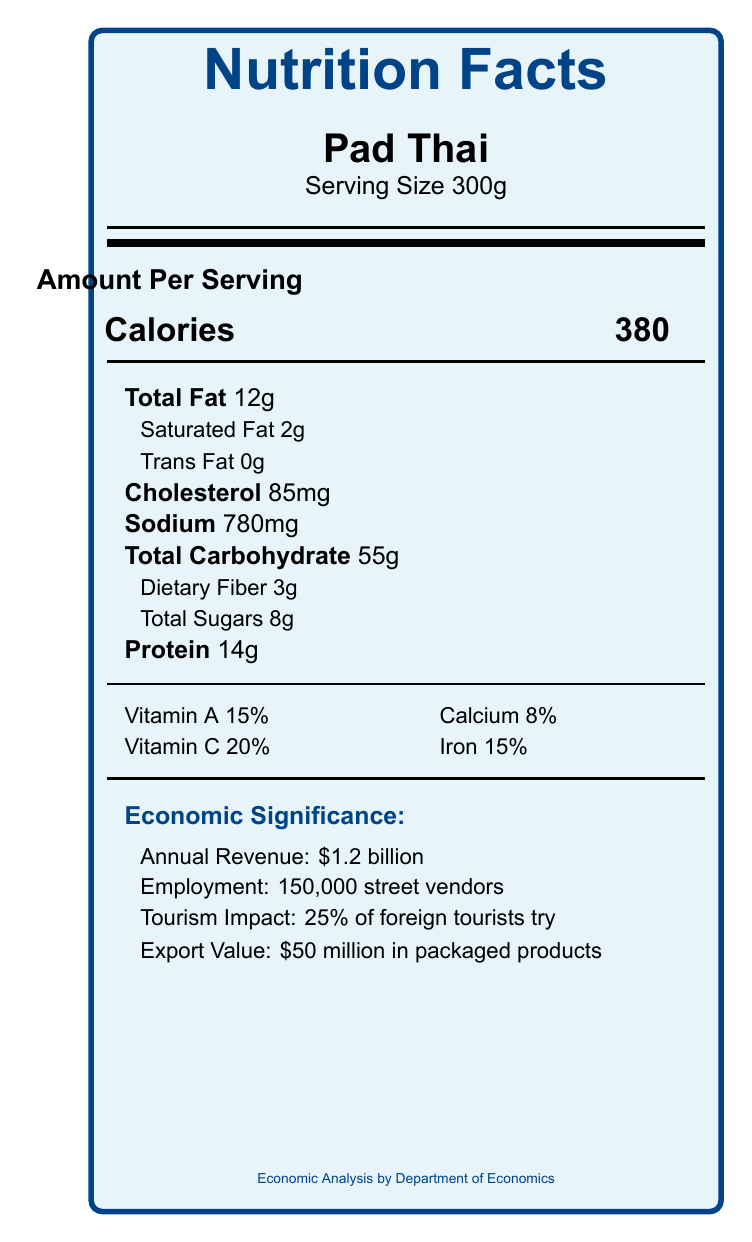what is the serving size of Pad Thai? The serving size is explicitly mentioned right below the title "Pad Thai" in the section of the document describing the food item.
Answer: 300g how much protein is in Pad Thai? The protein content is listed under the nutritional content section for Pad Thai.
Answer: 14g what percentage of foreign tourists try Pad Thai? The tourism impact is listed under the economic significance section for Pad Thai, stating that 25% of foreign tourists try it.
Answer: 25% how many street vendors are employed in the Takoyaki industry? Under the economic significance section for Takoyaki, the employment number is listed as 80,000 street vendors.
Answer: 80,000 what is the annual revenue from Bánh Mì? The annual revenue for Bánh Mì is listed under its economic significance section.
Answer: $800 million which street food has the least calories per serving? A. Pad Thai B. Bánh Mì C. Takoyaki The calorie content for Pad Thai is 380, for Bánh Mì is 320, and for Takoyaki is 280. Takoyaki has the least calories per serving.
Answer: C which of the following has the highest export value? I. Pad Thai II. Bánh Mì III. Takoyaki The export values are $50 million for Pad Thai, $30 million for Bánh Mì, and $20 million for Takoyaki. Pad Thai has the highest export value.
Answer: I is the sodium content higher in Pad Thai than in Bánh Mì? The sodium content is 780mg in Pad Thai and 650mg in Bánh Mì, so Pad Thai has a higher sodium content.
Answer: Yes summarize the nutritional and economic information provided about Pad Thai. This summary captures both the nutritional and economic aspects of Pad Thai, including serving size, macronutrient, micronutrient details, and key economic figures like revenue, employment, tourism impact, and export value.
Answer: Pad Thai has a serving size of 300g, providing 380 calories. It contains 12g of total fat, 2g of saturated fat, 0g of trans fat, 85mg of cholesterol, 780mg of sodium, 55g of total carbohydrates, 3g of dietary fiber, 8g of total sugars, and 14g of protein. It also supplies 15% of the daily value for vitamin A, 20% for vitamin C, 8% for calcium, and 15% for iron. Economically, it generates $1.2 billion in annual revenue, employs 150,000 street vendors, attracts 25% of foreign tourists, and has a $50 million export value in packaged products. what are the health benefits of street foods like Bánh Mì and Takoyaki? The document focuses on nutritional content and economic significance but does not provide specific health benefits or comparative data on health impacts.
Answer: Cannot be determined what role does street food play in contributing to food security according to the document? Under the political stability factors, the document states that street food contributes to food security by providing affordable nutrition.
Answer: Street food contributes to affordable nutrition for low-income populations. 